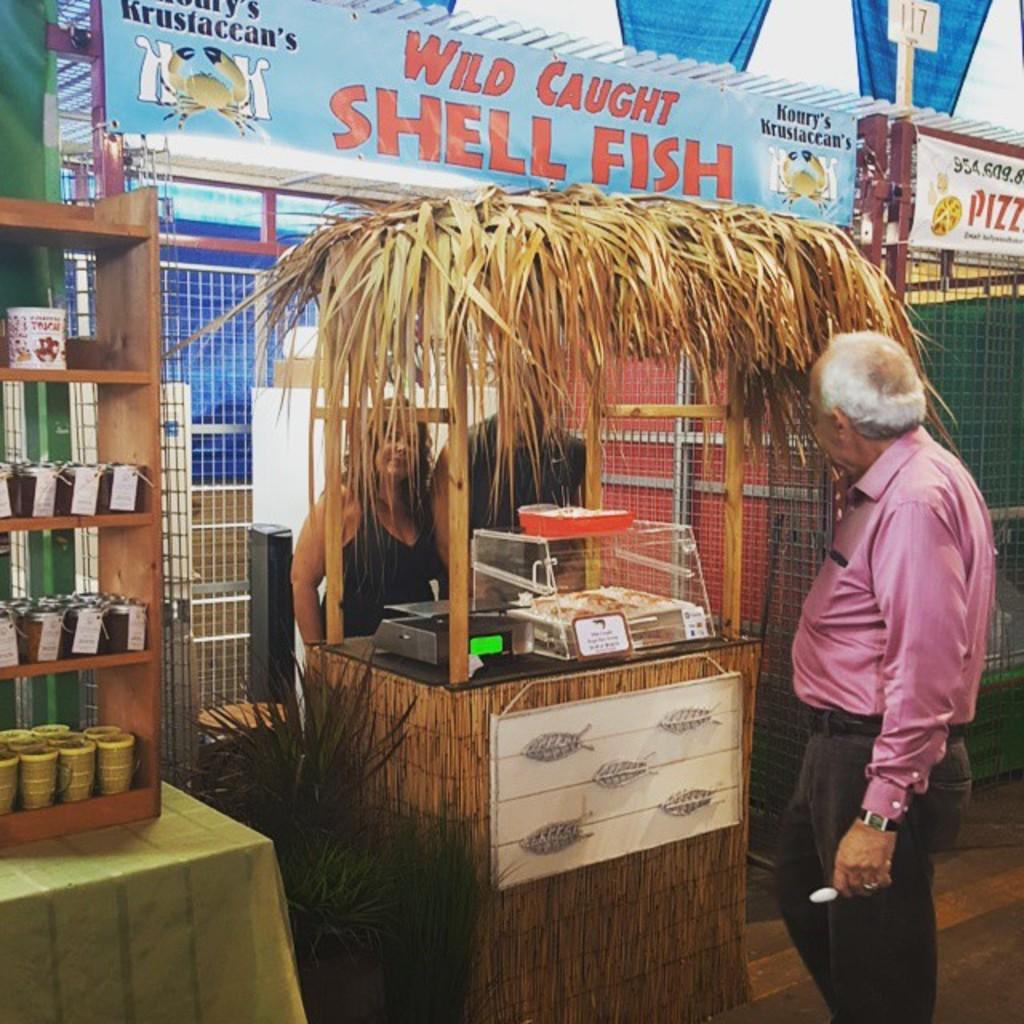What kind of fish are being sold?
Make the answer very short. Shell fish. Is pizza available somewhere too?
Give a very brief answer. Yes. 